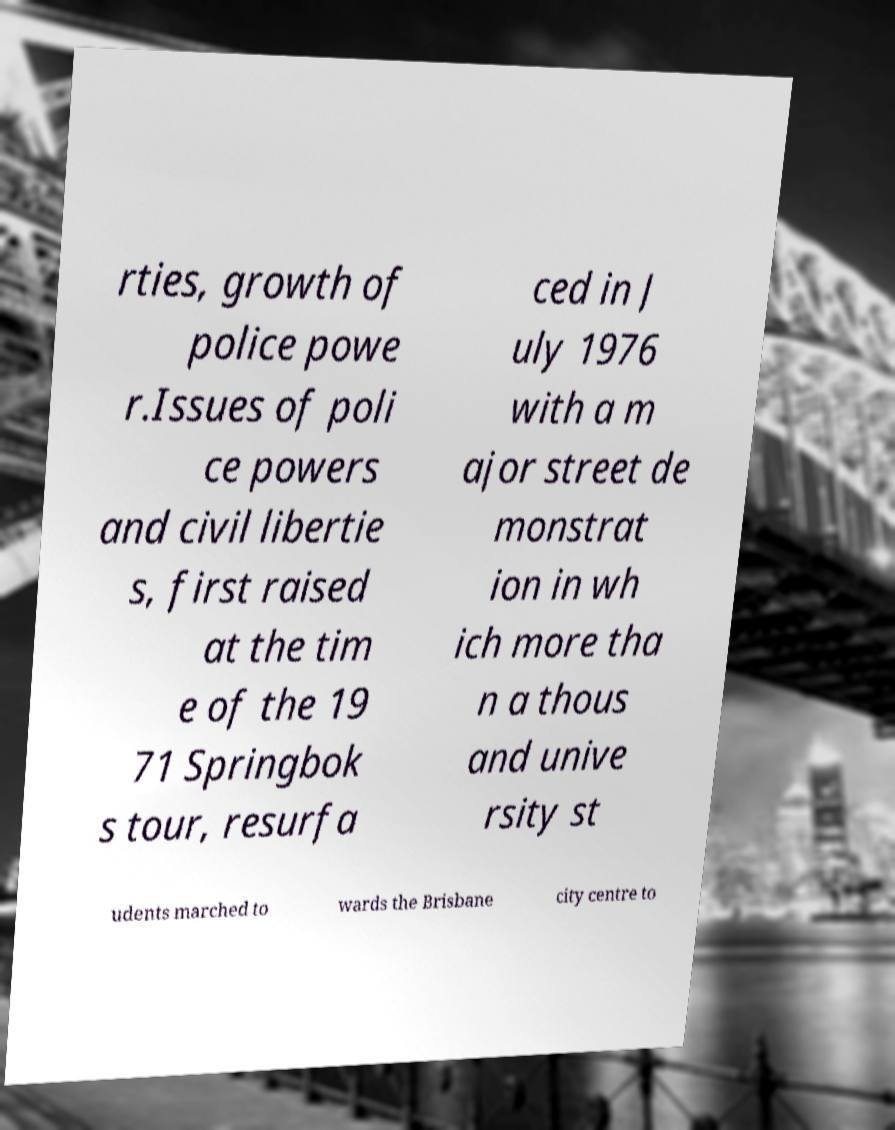Could you extract and type out the text from this image? rties, growth of police powe r.Issues of poli ce powers and civil libertie s, first raised at the tim e of the 19 71 Springbok s tour, resurfa ced in J uly 1976 with a m ajor street de monstrat ion in wh ich more tha n a thous and unive rsity st udents marched to wards the Brisbane city centre to 